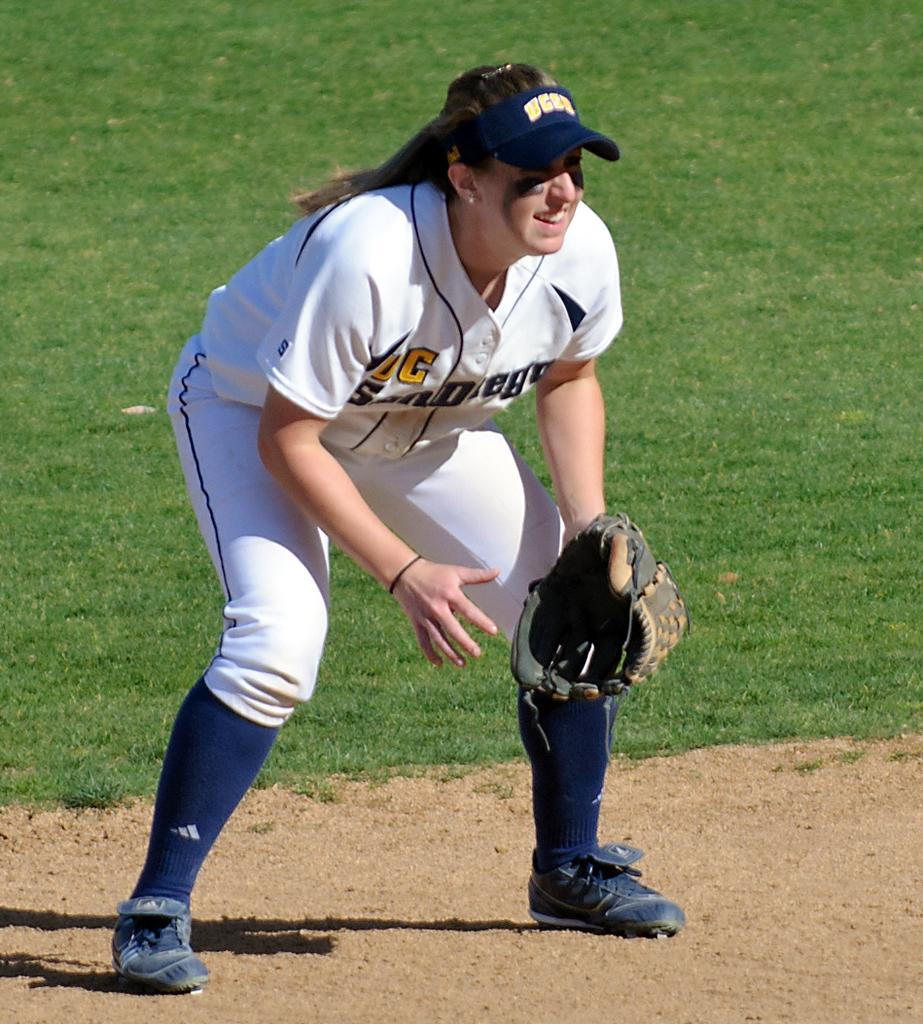<image>
Give a short and clear explanation of the subsequent image. Female baseball player wearing a blue visor that says UCS. 